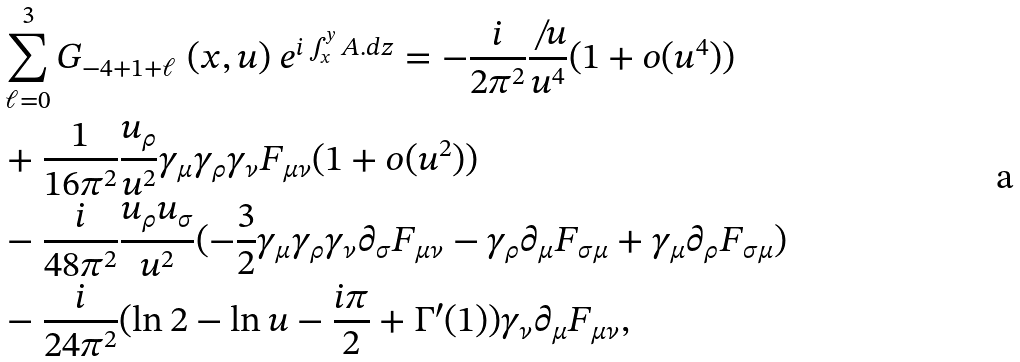<formula> <loc_0><loc_0><loc_500><loc_500>& \sum _ { \ell = 0 } ^ { 3 } G _ { - 4 + 1 + \ell } \ ( x , u ) \ e ^ { i \int _ { x } ^ { y } A . d z } = - \frac { i } { 2 \pi ^ { 2 } } \frac { \not \, u } { u ^ { 4 } } ( 1 + o ( u ^ { 4 } ) ) \\ & + \frac { 1 } { 1 6 \pi ^ { 2 } } \frac { u _ { \rho } } { u ^ { 2 } } \gamma _ { \mu } \gamma _ { \rho } \gamma _ { \nu } F _ { \mu \nu } ( 1 + o ( u ^ { 2 } ) ) \\ & - \frac { i } { 4 8 \pi ^ { 2 } } \frac { u _ { \rho } u _ { \sigma } } { u ^ { 2 } } ( - \frac { 3 } { 2 } \gamma _ { \mu } \gamma _ { \rho } \gamma _ { \nu } \partial _ { \sigma } F _ { \mu \nu } - \gamma _ { \rho } \partial _ { \mu } F _ { \sigma \mu } + \gamma _ { \mu } \partial _ { \rho } F _ { \sigma \mu } ) \\ & - \frac { i } { 2 4 \pi ^ { 2 } } ( \ln 2 - \ln u - \frac { i \pi } { 2 } + \Gamma ^ { \prime } ( 1 ) ) \gamma _ { \nu } \partial _ { \mu } F _ { \mu \nu } ,</formula> 